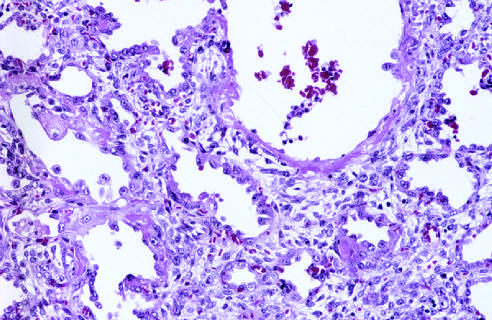what are seen at this stage, associated with regeneration and repair?
Answer the question using a single word or phrase. Numerous reactive type ii pneumocytes 